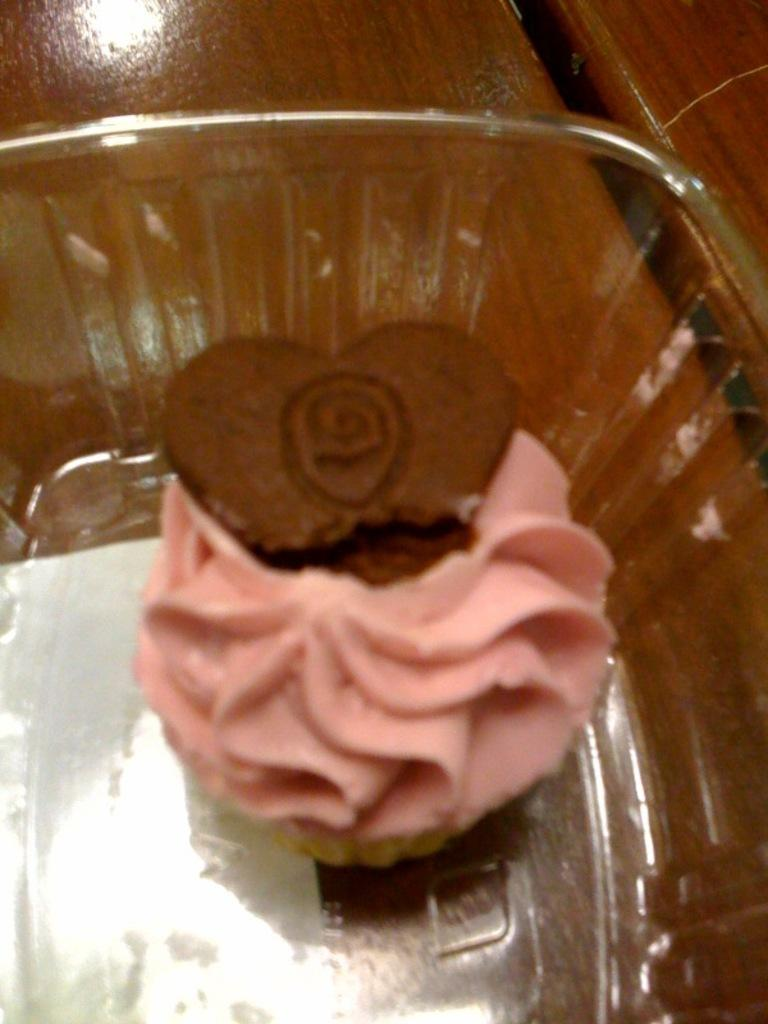How many tables can be seen in the image? There are two tables in the image. What is on one of the tables? There is a bowl with food on one of the tables. Can you describe the object under the bowl on the left side of the image? There is a white object under the bowl on the left side of the image. What type of bone can be seen in the image? There is no bone present in the image. Can you describe the crook used by the shepherd in the image? There is no shepherd or crook present in the image. 